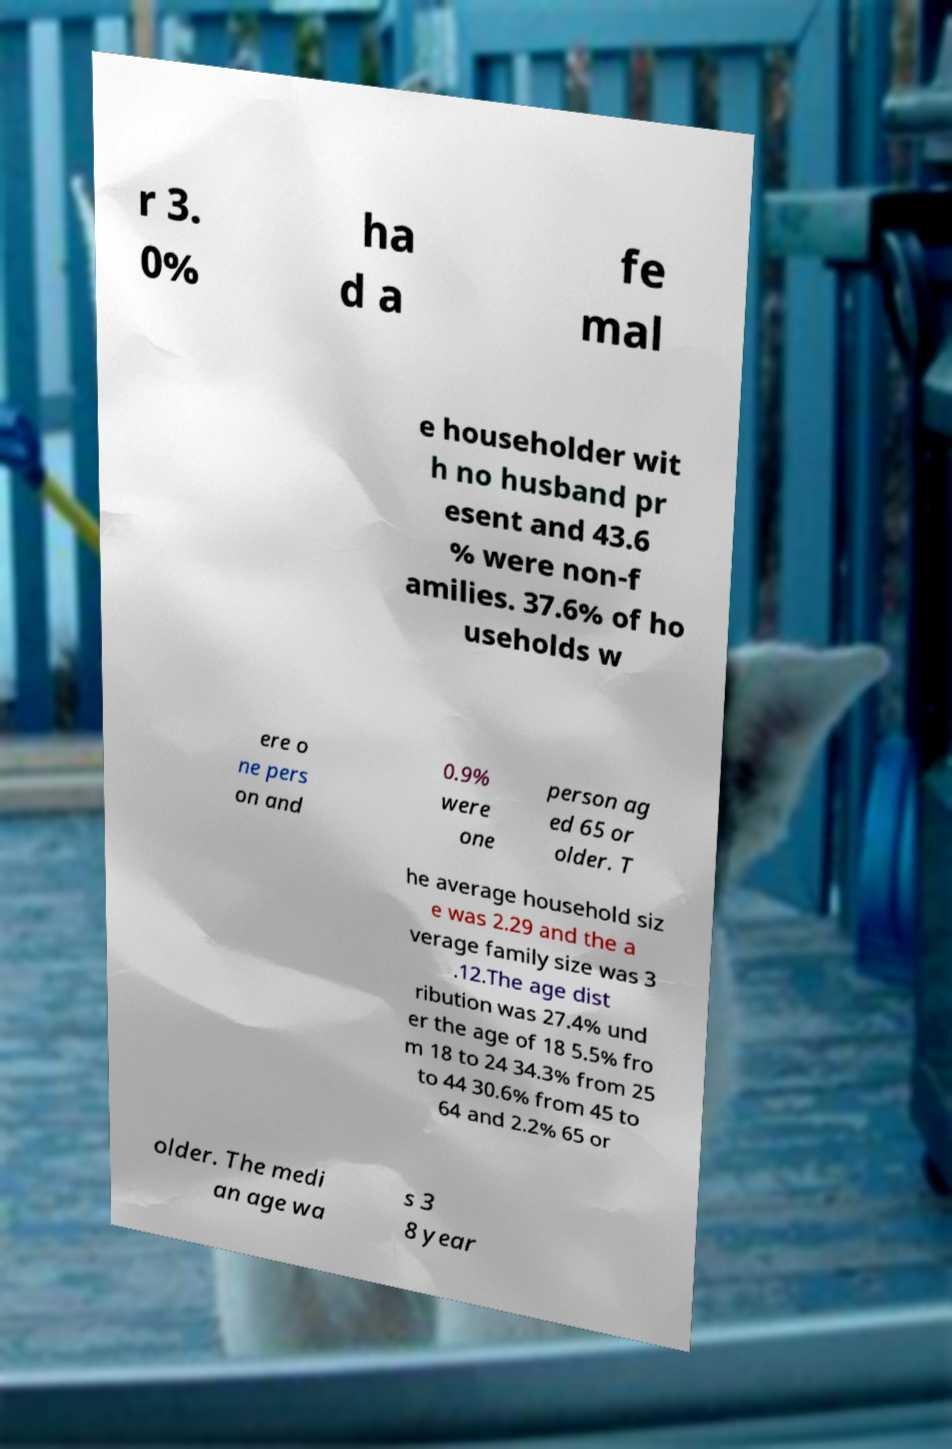What messages or text are displayed in this image? I need them in a readable, typed format. r 3. 0% ha d a fe mal e householder wit h no husband pr esent and 43.6 % were non-f amilies. 37.6% of ho useholds w ere o ne pers on and 0.9% were one person ag ed 65 or older. T he average household siz e was 2.29 and the a verage family size was 3 .12.The age dist ribution was 27.4% und er the age of 18 5.5% fro m 18 to 24 34.3% from 25 to 44 30.6% from 45 to 64 and 2.2% 65 or older. The medi an age wa s 3 8 year 